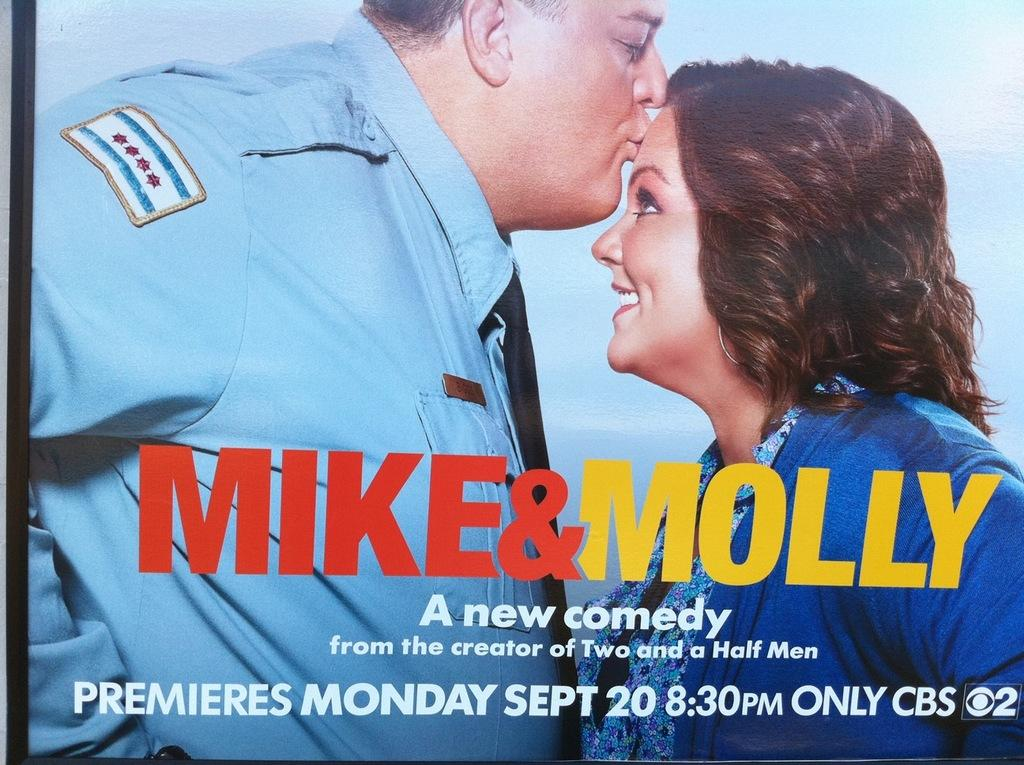What type of image is being described? The image is a poster. Who can be seen in the poster? There is a man and a woman in the poster. What is the man doing in the poster? The man is kissing the woman on her forehead. What type of dress is the pancake wearing in the image? There is no pancake or dress present in the image. 